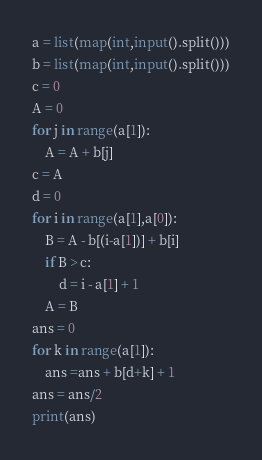<code> <loc_0><loc_0><loc_500><loc_500><_Python_>a = list(map(int,input().split()))
b = list(map(int,input().split()))
c = 0
A = 0
for j in range(a[1]):
    A = A + b[j]
c = A
d = 0
for i in range(a[1],a[0]):
    B = A - b[(i-a[1])] + b[i]
    if B > c:
        d = i - a[1] + 1
    A = B
ans = 0
for k in range(a[1]):
    ans =ans + b[d+k] + 1
ans = ans/2
print(ans)</code> 